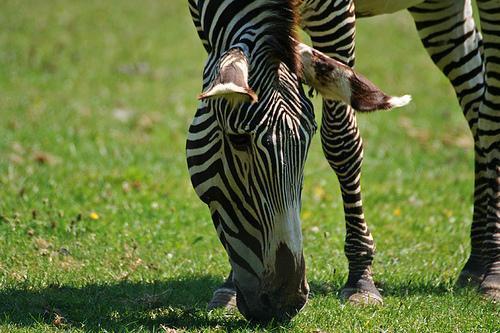How many hooves are visible?
Give a very brief answer. 4. How many people are wearing orange jackets?
Give a very brief answer. 0. 